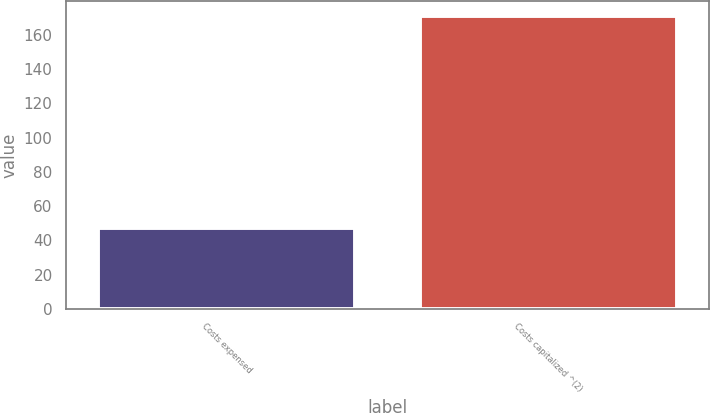Convert chart to OTSL. <chart><loc_0><loc_0><loc_500><loc_500><bar_chart><fcel>Costs expensed<fcel>Costs capitalized ^(2)<nl><fcel>47<fcel>171<nl></chart> 